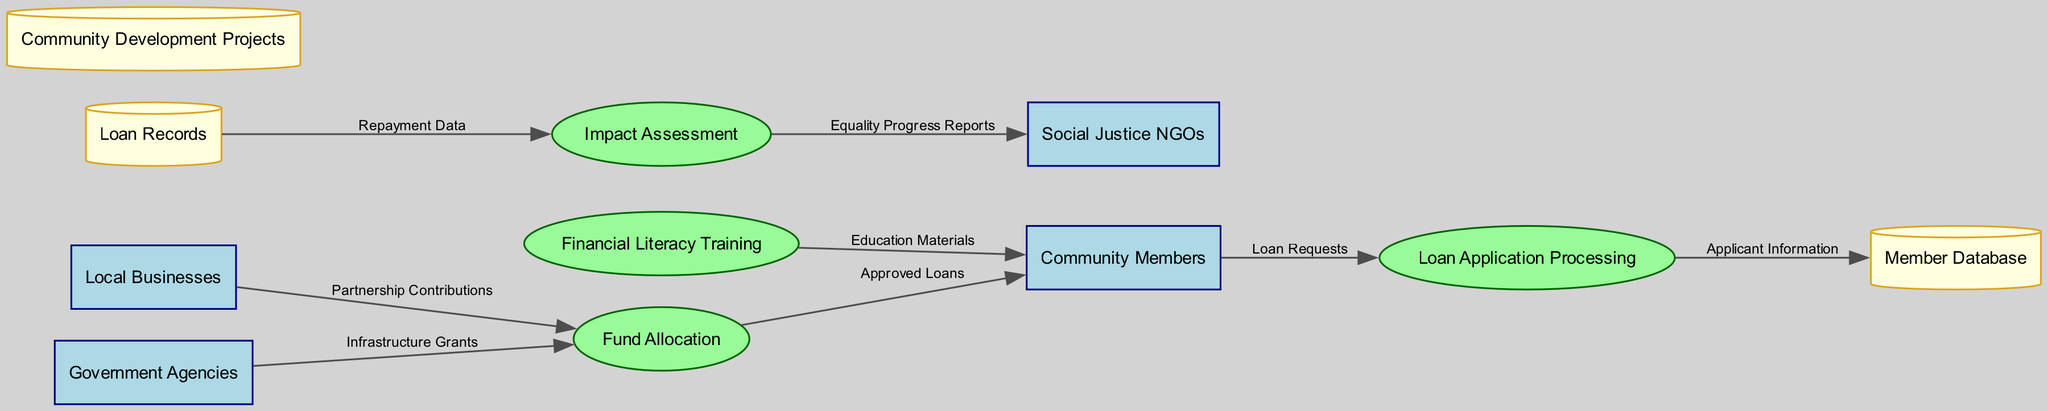What are the four external entities in the diagram? There are four external entities identified in the diagram: Community Members, Local Businesses, Social Justice NGOs, and Government Agencies.
Answer: Community Members, Local Businesses, Social Justice NGOs, Government Agencies Which process receives Loan Requests? The Loan Requests flow from the Community Members to the Loan Application Processing process. Therefore, the process that receives Loan Requests is Loan Application Processing.
Answer: Loan Application Processing How many data stores are present in the diagram? The diagram lists three data stores: Member Database, Loan Records, and Community Development Projects. Therefore, the total number of data stores is three.
Answer: 3 What type of data flows from the Fund Allocation process to Community Members? The data flow from the Fund Allocation process to Community Members is labeled as Approved Loans. This indicates the type of data being transferred in this flow.
Answer: Approved Loans Which external entity provides Infrastructure Grants? The external entity that provides Infrastructure Grants is Government Agencies, as indicated by the flow from Government Agencies to Fund Allocation labeled as Infrastructure Grants.
Answer: Government Agencies What data flows from Local Businesses to Fund Allocation? The data that flows from Local Businesses to Fund Allocation is labeled as Partnership Contributions, indicating the nature of the contribution made by Local Businesses.
Answer: Partnership Contributions How does Impact Assessment relate to Social Justice NGOs? The Impact Assessment process sends a data flow labeled Equality Progress Reports to Social Justice NGOs, signifying a relationship where impact results are communicated to those organizations.
Answer: Equality Progress Reports Which process is the last one to receive data from Loan Records? The Impact Assessment process is the final one in the flow that receives data from Loan Records. This is indicated by the data flow from Loan Records to Impact Assessment labeled as Repayment Data.
Answer: Impact Assessment What type of materials are provided to Community Members by Financial Literacy Training? The data flow from Financial Literacy Training to Community Members is labeled as Education Materials, indicating the content being provided in this training.
Answer: Education Materials What is the primary function of the Loan Application Processing process? The primary function of the Loan Application Processing process is to handle the Loan Requests from Community Members, as inferred from its position and the data flow labeled Loan Requests.
Answer: Handle Loan Requests 